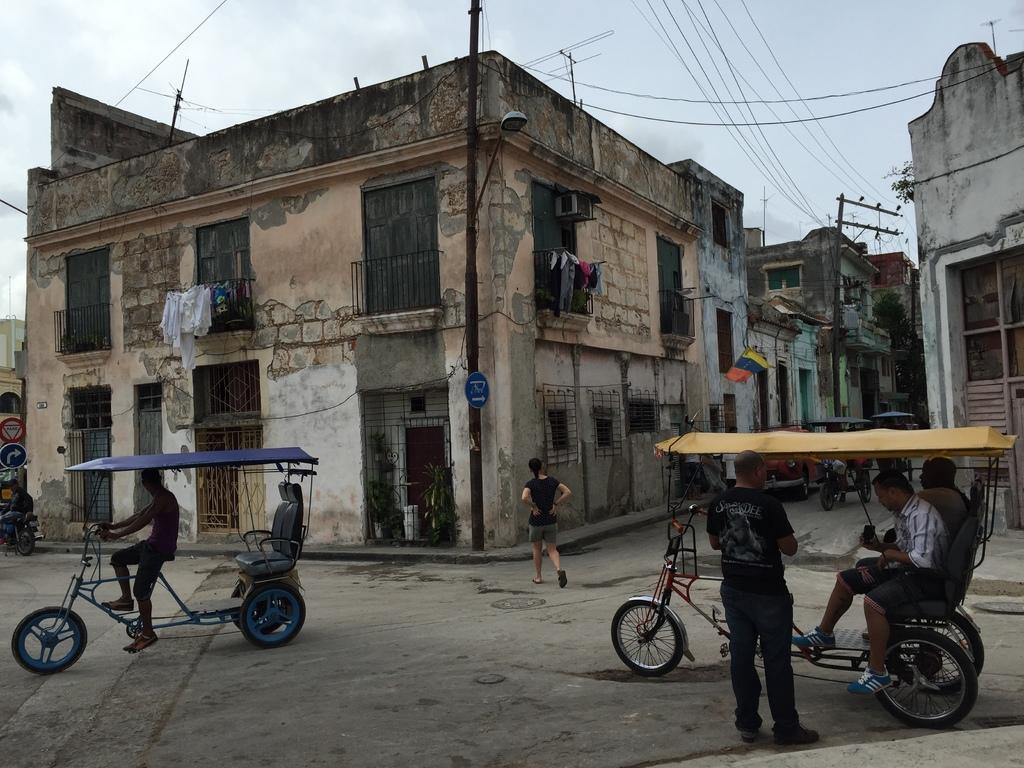Could you give a brief overview of what you see in this image? In this image we can see the buildings, electrical poles, wires and also the clothes. We can also see the vehicles, people, path and also the cloudy sky in the background. 